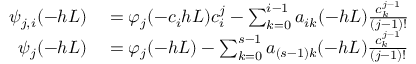Convert formula to latex. <formula><loc_0><loc_0><loc_500><loc_500>\begin{array} { r l } { \psi _ { j , i } ( - h L ) } & = \varphi _ { j } ( - c _ { i } h L ) c _ { i } ^ { j } - \sum _ { k = 0 } ^ { i - 1 } a _ { i k } ( - h L ) \frac { c _ { k } ^ { j - 1 } } { ( j - 1 ) ! } } \\ { \psi _ { j } ( - h L ) } & = \varphi _ { j } ( - h L ) - \sum _ { k = 0 } ^ { s - 1 } a _ { ( s - 1 ) k } ( - h L ) \frac { c _ { k } ^ { j - 1 } } { ( j - 1 ) ! } } \end{array}</formula> 